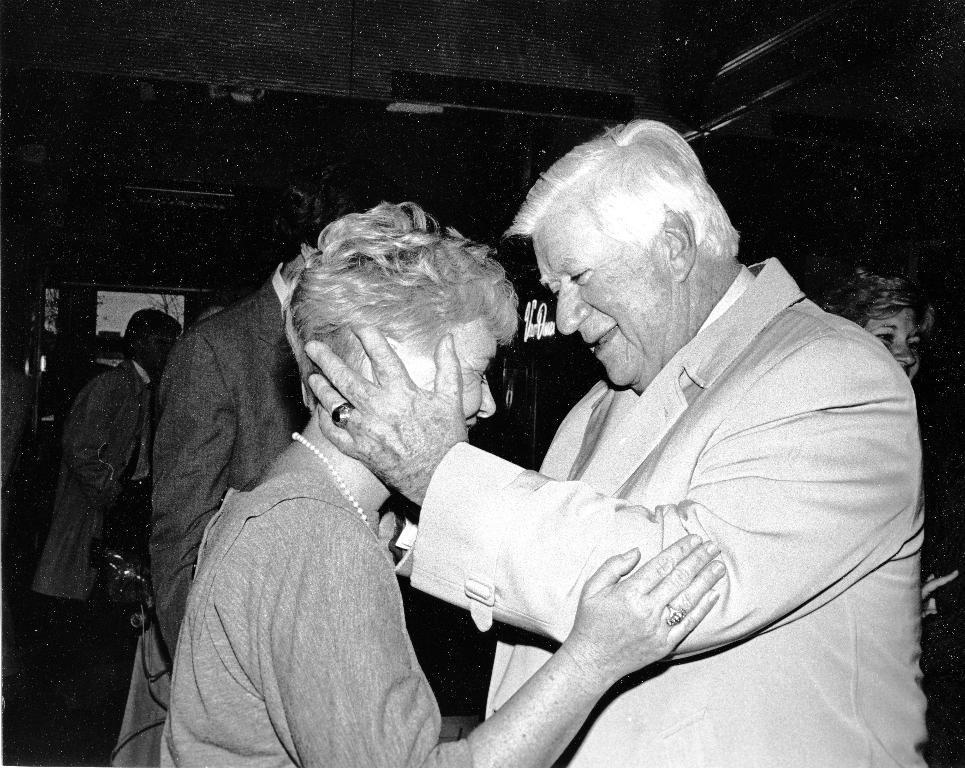Could you give a brief overview of what you see in this image? In this picture we can see a man holding a woman. Few people and some trees are visible in the background. 